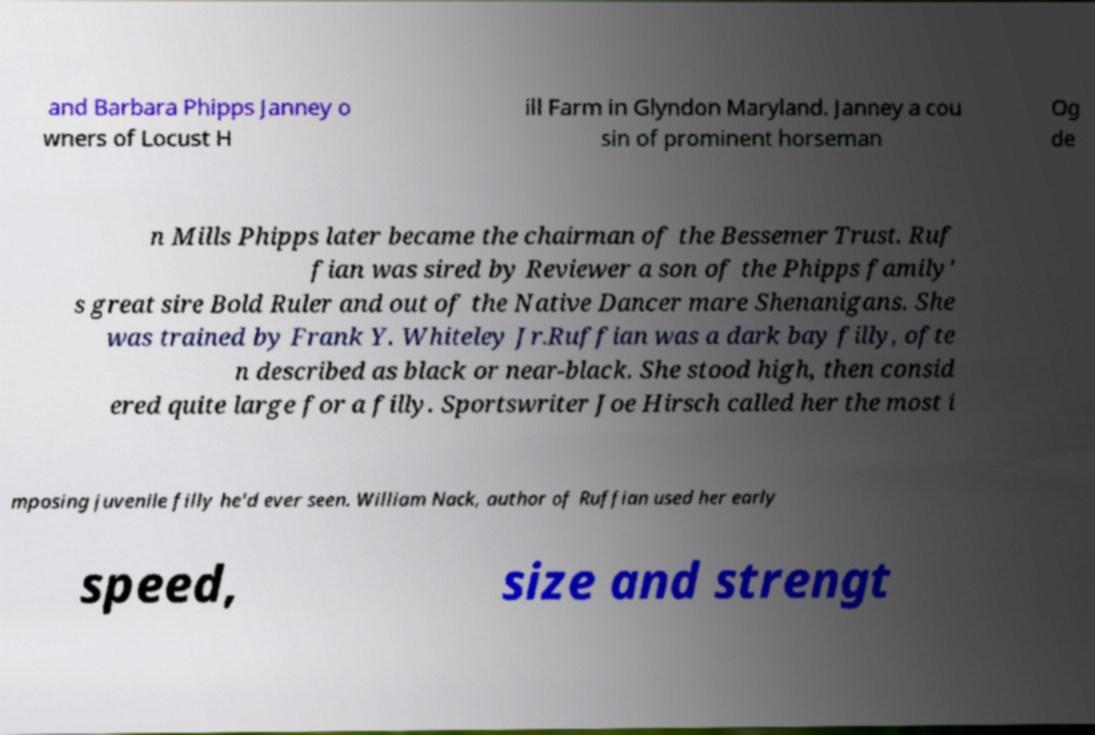Please identify and transcribe the text found in this image. and Barbara Phipps Janney o wners of Locust H ill Farm in Glyndon Maryland. Janney a cou sin of prominent horseman Og de n Mills Phipps later became the chairman of the Bessemer Trust. Ruf fian was sired by Reviewer a son of the Phipps family' s great sire Bold Ruler and out of the Native Dancer mare Shenanigans. She was trained by Frank Y. Whiteley Jr.Ruffian was a dark bay filly, ofte n described as black or near-black. She stood high, then consid ered quite large for a filly. Sportswriter Joe Hirsch called her the most i mposing juvenile filly he'd ever seen. William Nack, author of Ruffian used her early speed, size and strengt 